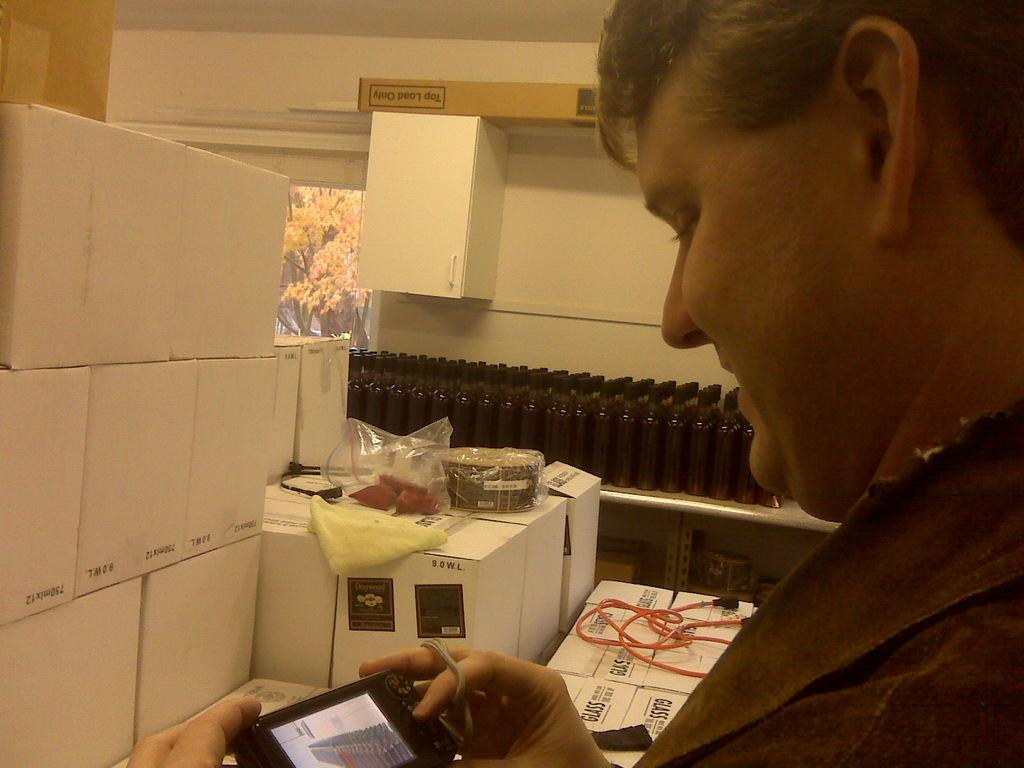Can you describe this image briefly? In this given picture, I can see a person holding a camera and they are certain packed boxes and i can see few boxes next i can see a connector and few black color bottles and i can see a wall picture which is sticked to the wall and in this picture i can see yellow flowers, trees and wall is colored with cream color 